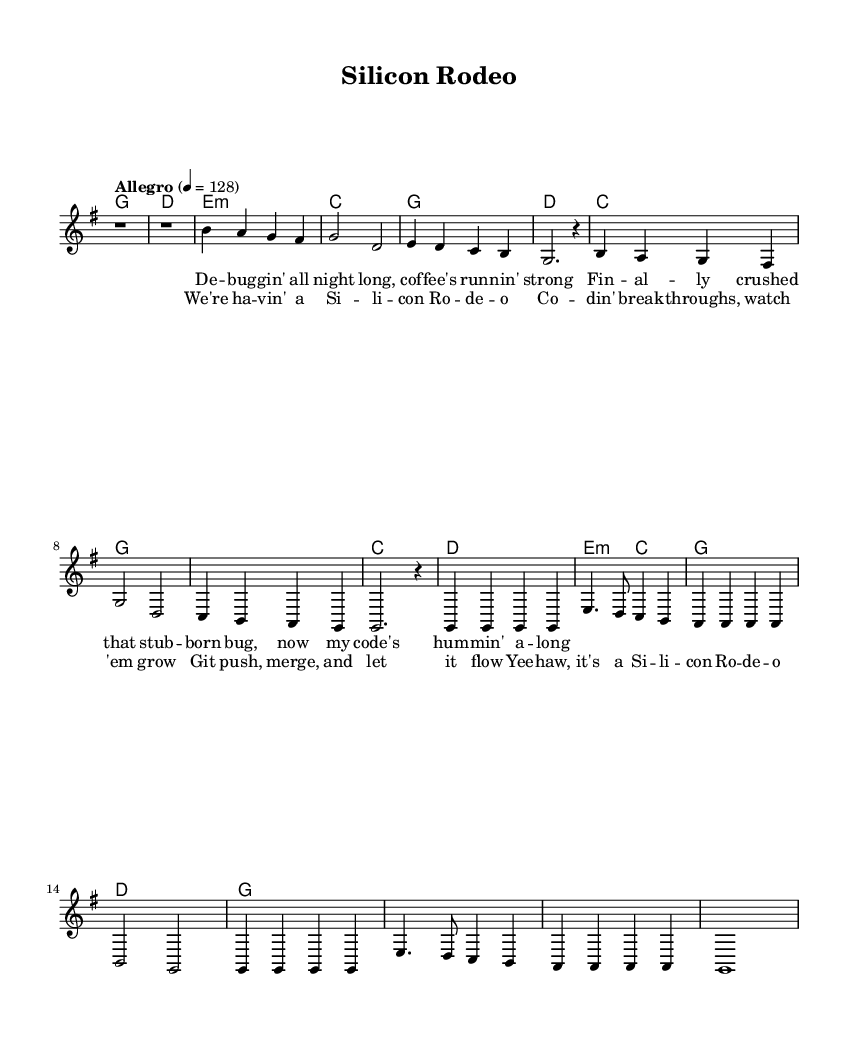What is the key signature of this music? The key signature indicated in the global section of the sheet music is G major, which has one sharp (F#).
Answer: G major What is the time signature of this piece? The time signature is shown in the global section as 4/4, indicating four beats in a measure with each quarter note receiving one beat.
Answer: 4/4 What is the tempo marking of the piece? The tempo marking is found in the global section, indicating to play the music at an "Allegro" tempo, which is commonly understood to be fast.
Answer: Allegro How many measures are there in the chorus? By counting the measures in the chorus section of the music, there are a total of eight measures.
Answer: Eight What is the first lyric of the song? The lyrics start with "De-bug-gin' all night long" as indicated in the verse section.
Answer: De-bug-gin' all night long What is the final chord of the chorus? The final chord of the chorus in the harmonies section is written as g1, indicating to play a G major chord.
Answer: G major What theme does this song celebrate? The lyrics emphasize coding breakthroughs and software releases, celebrating achievements in technology and programming.
Answer: Coding breakthroughs 